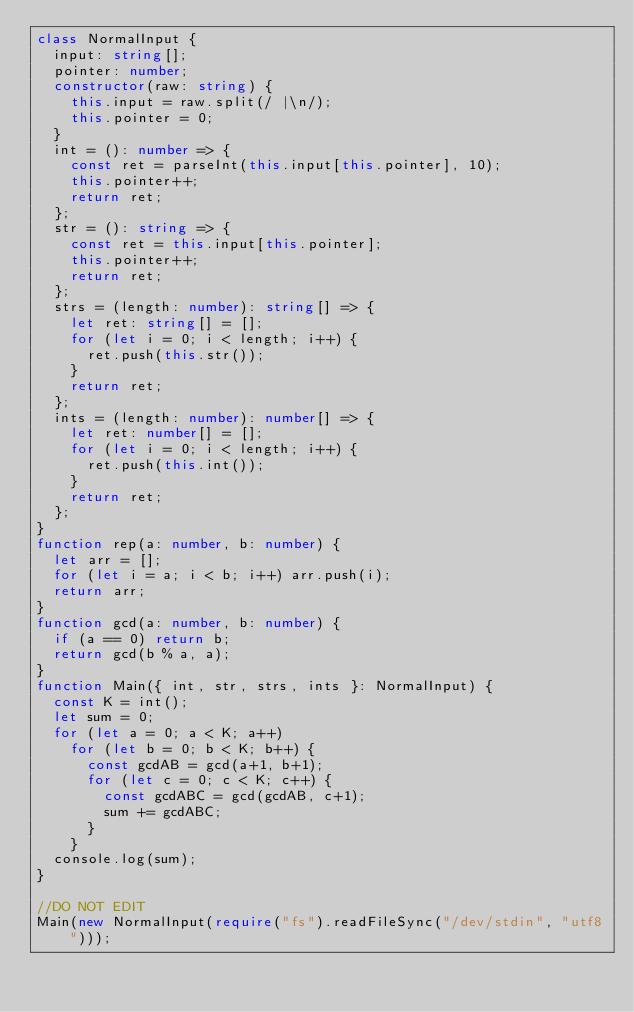<code> <loc_0><loc_0><loc_500><loc_500><_TypeScript_>class NormalInput {
  input: string[];
  pointer: number;
  constructor(raw: string) {
    this.input = raw.split(/ |\n/);
    this.pointer = 0;
  }
  int = (): number => {
    const ret = parseInt(this.input[this.pointer], 10);
    this.pointer++;
    return ret;
  };
  str = (): string => {
    const ret = this.input[this.pointer];
    this.pointer++;
    return ret;
  };
  strs = (length: number): string[] => {
    let ret: string[] = [];
    for (let i = 0; i < length; i++) {
      ret.push(this.str());
    }
    return ret;
  };
  ints = (length: number): number[] => {
    let ret: number[] = [];
    for (let i = 0; i < length; i++) {
      ret.push(this.int());
    }
    return ret;
  };
}
function rep(a: number, b: number) {
  let arr = [];
  for (let i = a; i < b; i++) arr.push(i);
  return arr;
}
function gcd(a: number, b: number) {
  if (a == 0) return b;
  return gcd(b % a, a);
}
function Main({ int, str, strs, ints }: NormalInput) {
  const K = int();
  let sum = 0;
  for (let a = 0; a < K; a++)
    for (let b = 0; b < K; b++) {
      const gcdAB = gcd(a+1, b+1);
      for (let c = 0; c < K; c++) {
        const gcdABC = gcd(gcdAB, c+1);
        sum += gcdABC;
      }
    }
  console.log(sum);
}

//DO NOT EDIT
Main(new NormalInput(require("fs").readFileSync("/dev/stdin", "utf8")));
</code> 